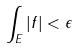<formula> <loc_0><loc_0><loc_500><loc_500>\int _ { E } | f | < \epsilon</formula> 